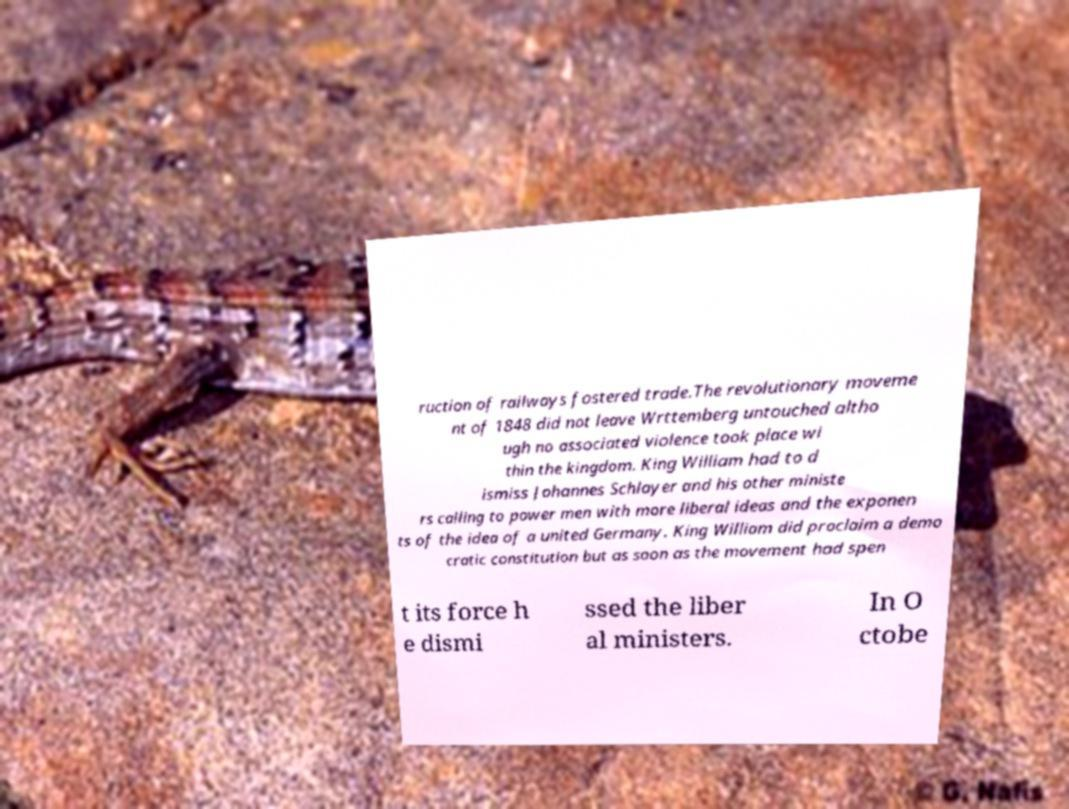Please identify and transcribe the text found in this image. ruction of railways fostered trade.The revolutionary moveme nt of 1848 did not leave Wrttemberg untouched altho ugh no associated violence took place wi thin the kingdom. King William had to d ismiss Johannes Schlayer and his other ministe rs calling to power men with more liberal ideas and the exponen ts of the idea of a united Germany. King William did proclaim a demo cratic constitution but as soon as the movement had spen t its force h e dismi ssed the liber al ministers. In O ctobe 